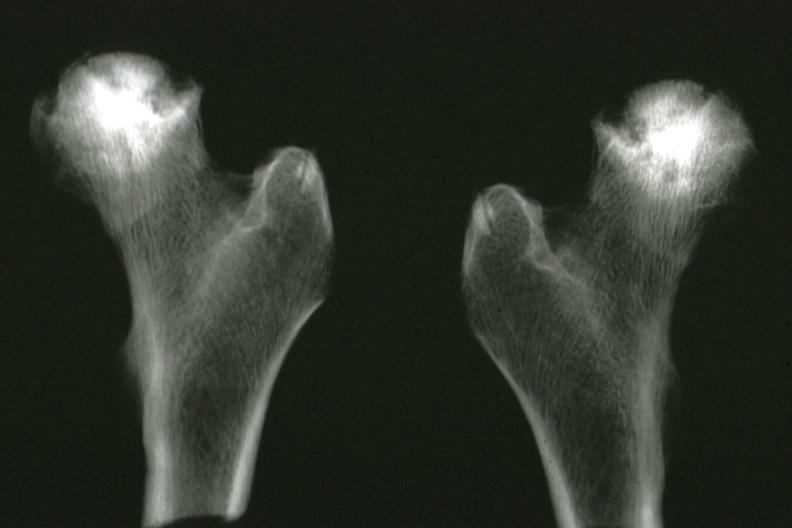does this image show x-ray of femoral heads removed at autopsy good illustration?
Answer the question using a single word or phrase. Yes 